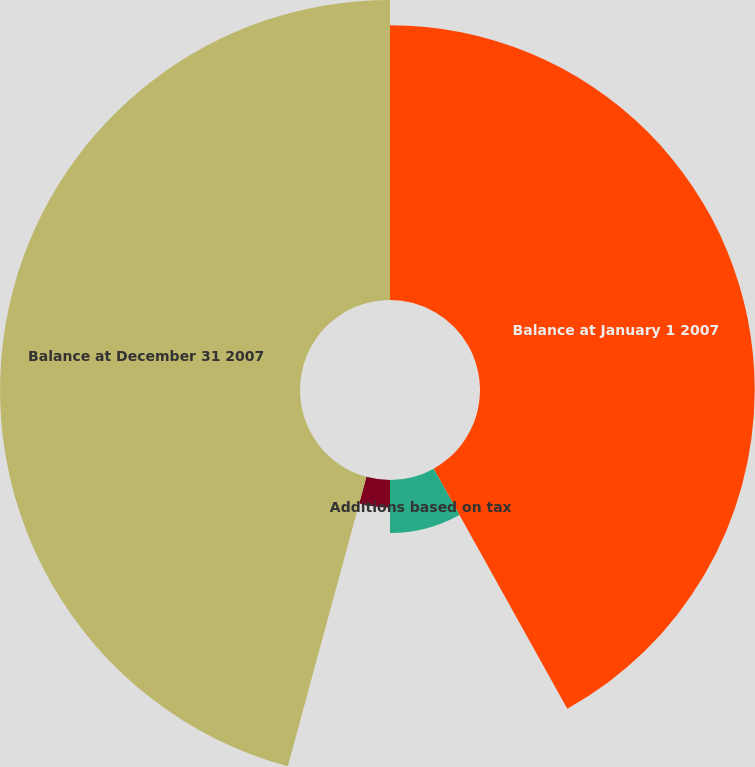<chart> <loc_0><loc_0><loc_500><loc_500><pie_chart><fcel>Balance at January 1 2007<fcel>Additions based on tax<fcel>Reductions for tax positions<fcel>Balance at December 31 2007<nl><fcel>41.92%<fcel>8.08%<fcel>4.22%<fcel>45.78%<nl></chart> 